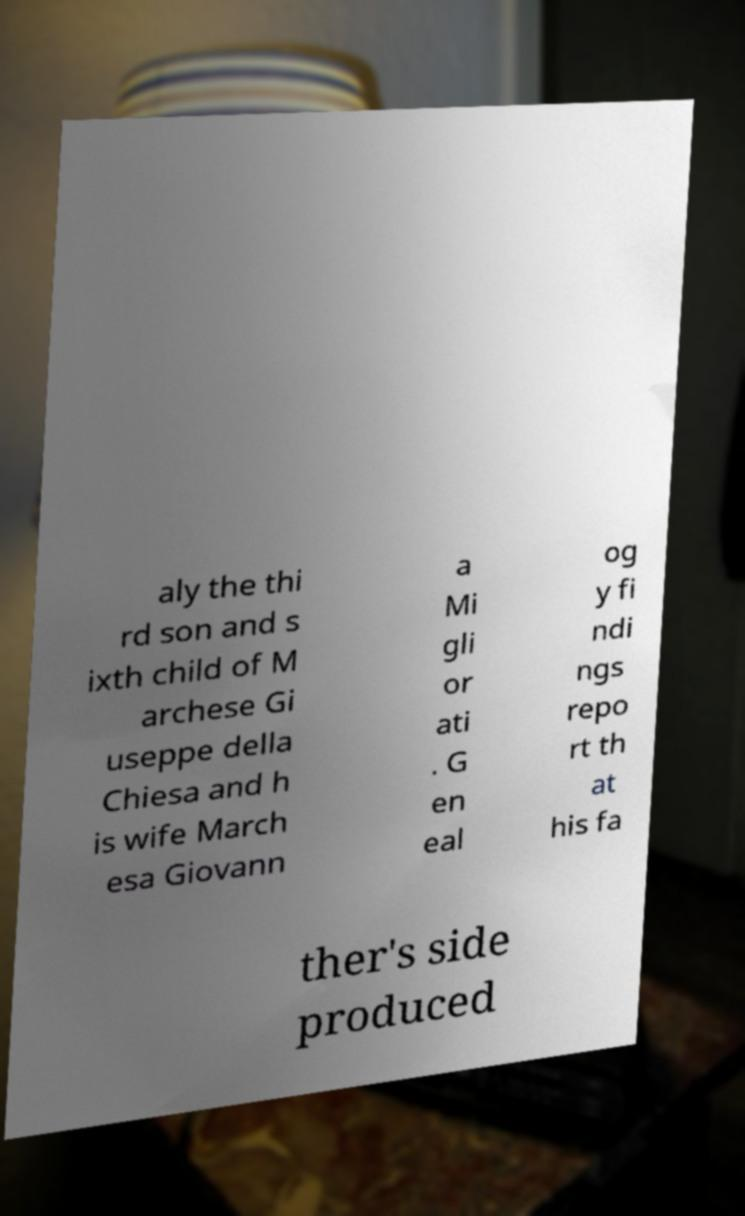Can you read and provide the text displayed in the image?This photo seems to have some interesting text. Can you extract and type it out for me? aly the thi rd son and s ixth child of M archese Gi useppe della Chiesa and h is wife March esa Giovann a Mi gli or ati . G en eal og y fi ndi ngs repo rt th at his fa ther's side produced 